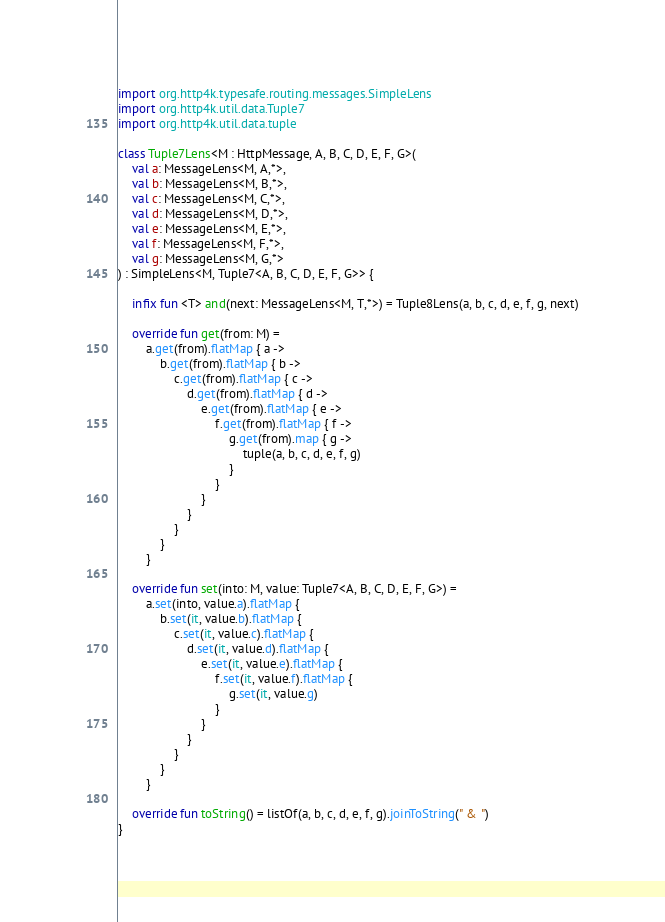<code> <loc_0><loc_0><loc_500><loc_500><_Kotlin_>import org.http4k.typesafe.routing.messages.SimpleLens
import org.http4k.util.data.Tuple7
import org.http4k.util.data.tuple

class Tuple7Lens<M : HttpMessage, A, B, C, D, E, F, G>(
    val a: MessageLens<M, A,*>,
    val b: MessageLens<M, B,*>,
    val c: MessageLens<M, C,*>,
    val d: MessageLens<M, D,*>,
    val e: MessageLens<M, E,*>,
    val f: MessageLens<M, F,*>,
    val g: MessageLens<M, G,*>
) : SimpleLens<M, Tuple7<A, B, C, D, E, F, G>> {

    infix fun <T> and(next: MessageLens<M, T,*>) = Tuple8Lens(a, b, c, d, e, f, g, next)

    override fun get(from: M) =
        a.get(from).flatMap { a ->
            b.get(from).flatMap { b ->
                c.get(from).flatMap { c ->
                    d.get(from).flatMap { d ->
                        e.get(from).flatMap { e ->
                            f.get(from).flatMap { f ->
                                g.get(from).map { g ->
                                    tuple(a, b, c, d, e, f, g)
                                }
                            }
                        }
                    }
                }
            }
        }

    override fun set(into: M, value: Tuple7<A, B, C, D, E, F, G>) =
        a.set(into, value.a).flatMap {
            b.set(it, value.b).flatMap {
                c.set(it, value.c).flatMap {
                    d.set(it, value.d).flatMap {
                        e.set(it, value.e).flatMap {
                            f.set(it, value.f).flatMap {
                                g.set(it, value.g)
                            }
                        }
                    }
                }
            }
        }

    override fun toString() = listOf(a, b, c, d, e, f, g).joinToString(" & ")
}
</code> 